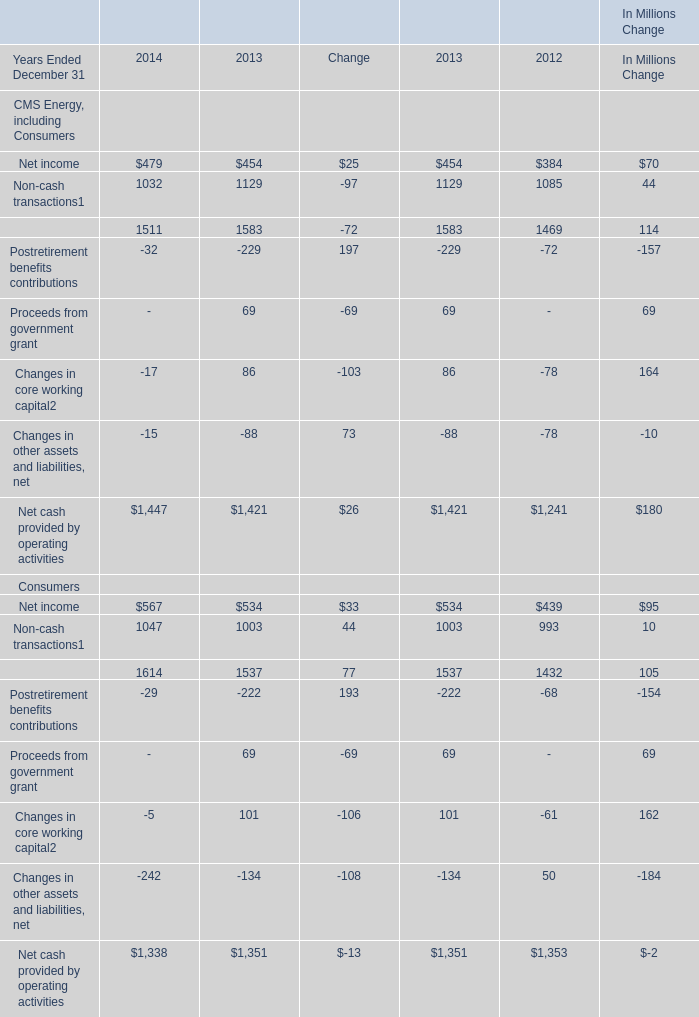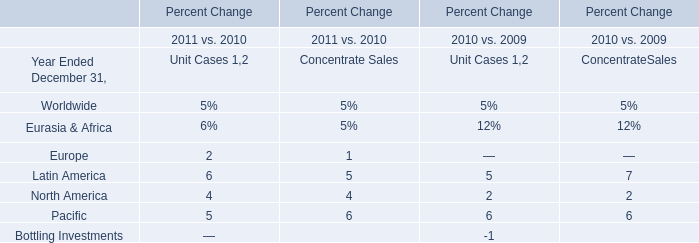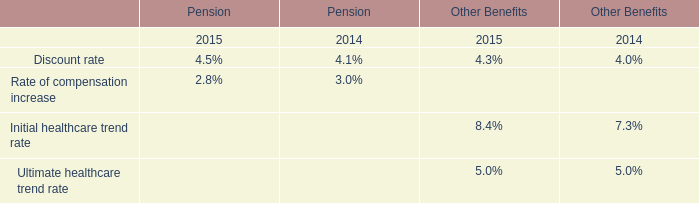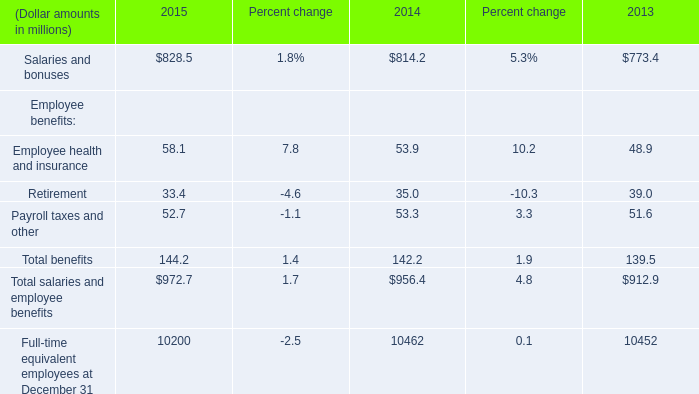What will Non-cash transactions of Consumers reach in 2015 if it continues to grow at its 2014 rate? (in million) 
Computations: (1047 * (1 + ((1047 - 1003) / 1003)))
Answer: 1092.93021. 